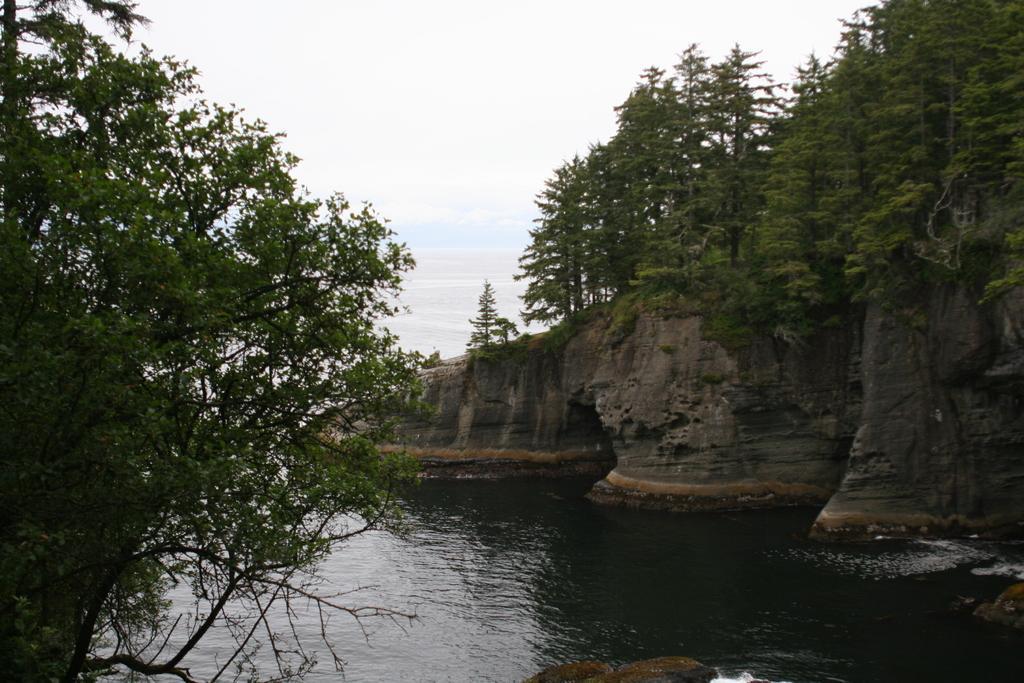Please provide a concise description of this image. This is an outside view. At the bottom of the image there is a sea. On the right side there is a rock. On the right and left side of the image there are few trees. At the top of the image I can see the sky. 